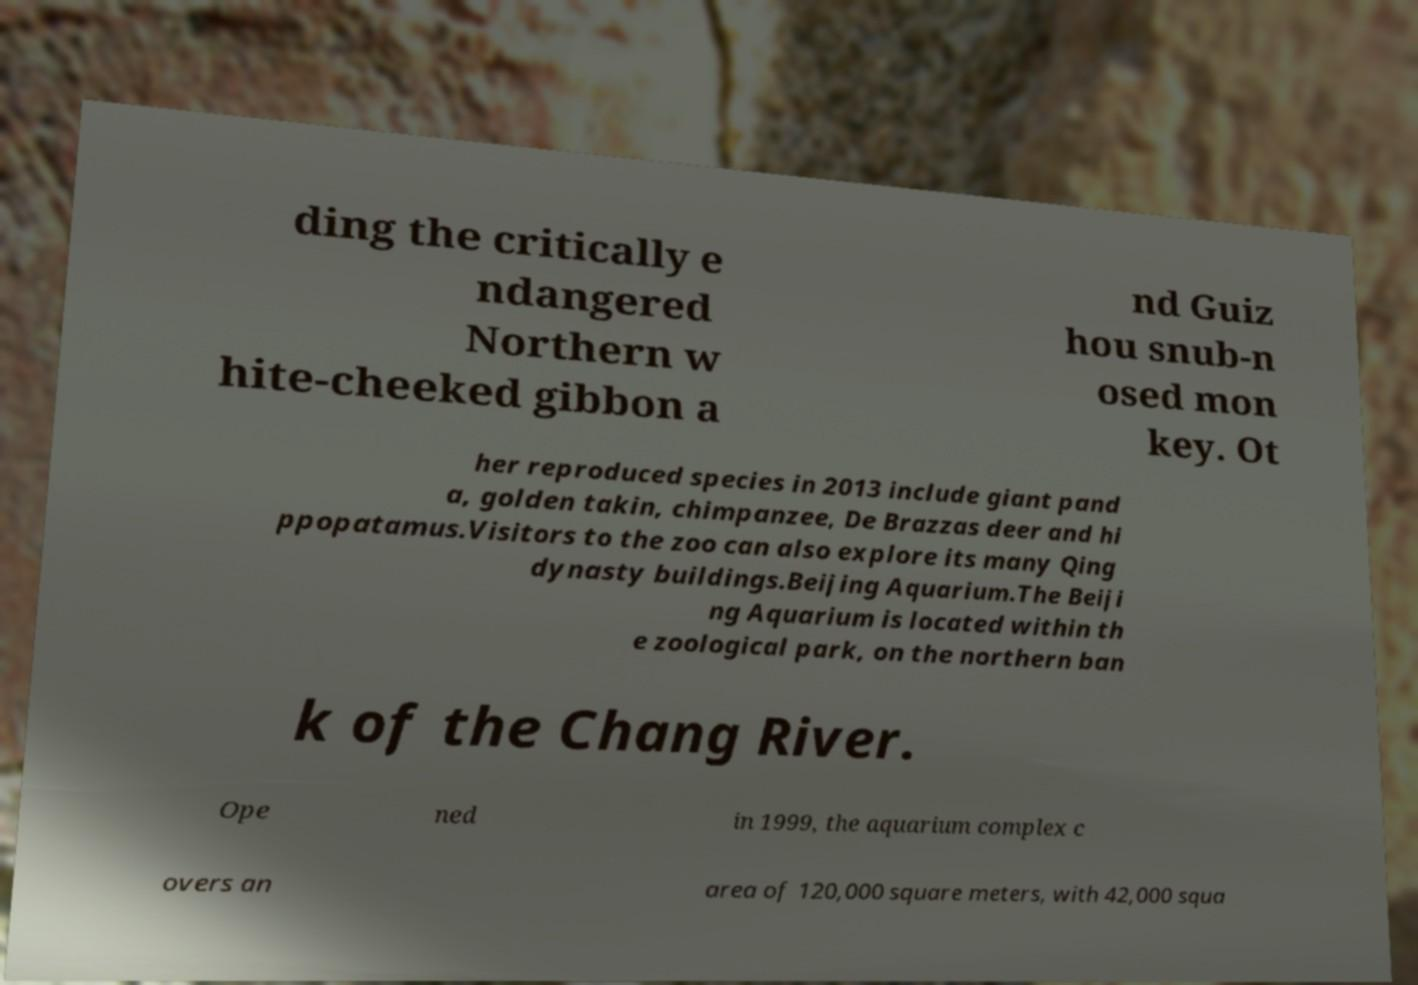For documentation purposes, I need the text within this image transcribed. Could you provide that? ding the critically e ndangered Northern w hite-cheeked gibbon a nd Guiz hou snub-n osed mon key. Ot her reproduced species in 2013 include giant pand a, golden takin, chimpanzee, De Brazzas deer and hi ppopatamus.Visitors to the zoo can also explore its many Qing dynasty buildings.Beijing Aquarium.The Beiji ng Aquarium is located within th e zoological park, on the northern ban k of the Chang River. Ope ned in 1999, the aquarium complex c overs an area of 120,000 square meters, with 42,000 squa 